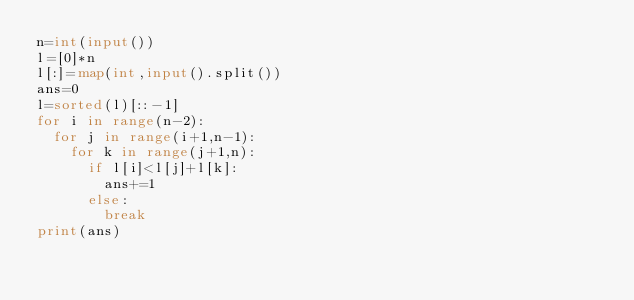Convert code to text. <code><loc_0><loc_0><loc_500><loc_500><_Python_>n=int(input())
l=[0]*n
l[:]=map(int,input().split())
ans=0
l=sorted(l)[::-1]
for i in range(n-2):
  for j in range(i+1,n-1):
    for k in range(j+1,n):
      if l[i]<l[j]+l[k]:
        ans+=1
      else:
        break
print(ans)</code> 